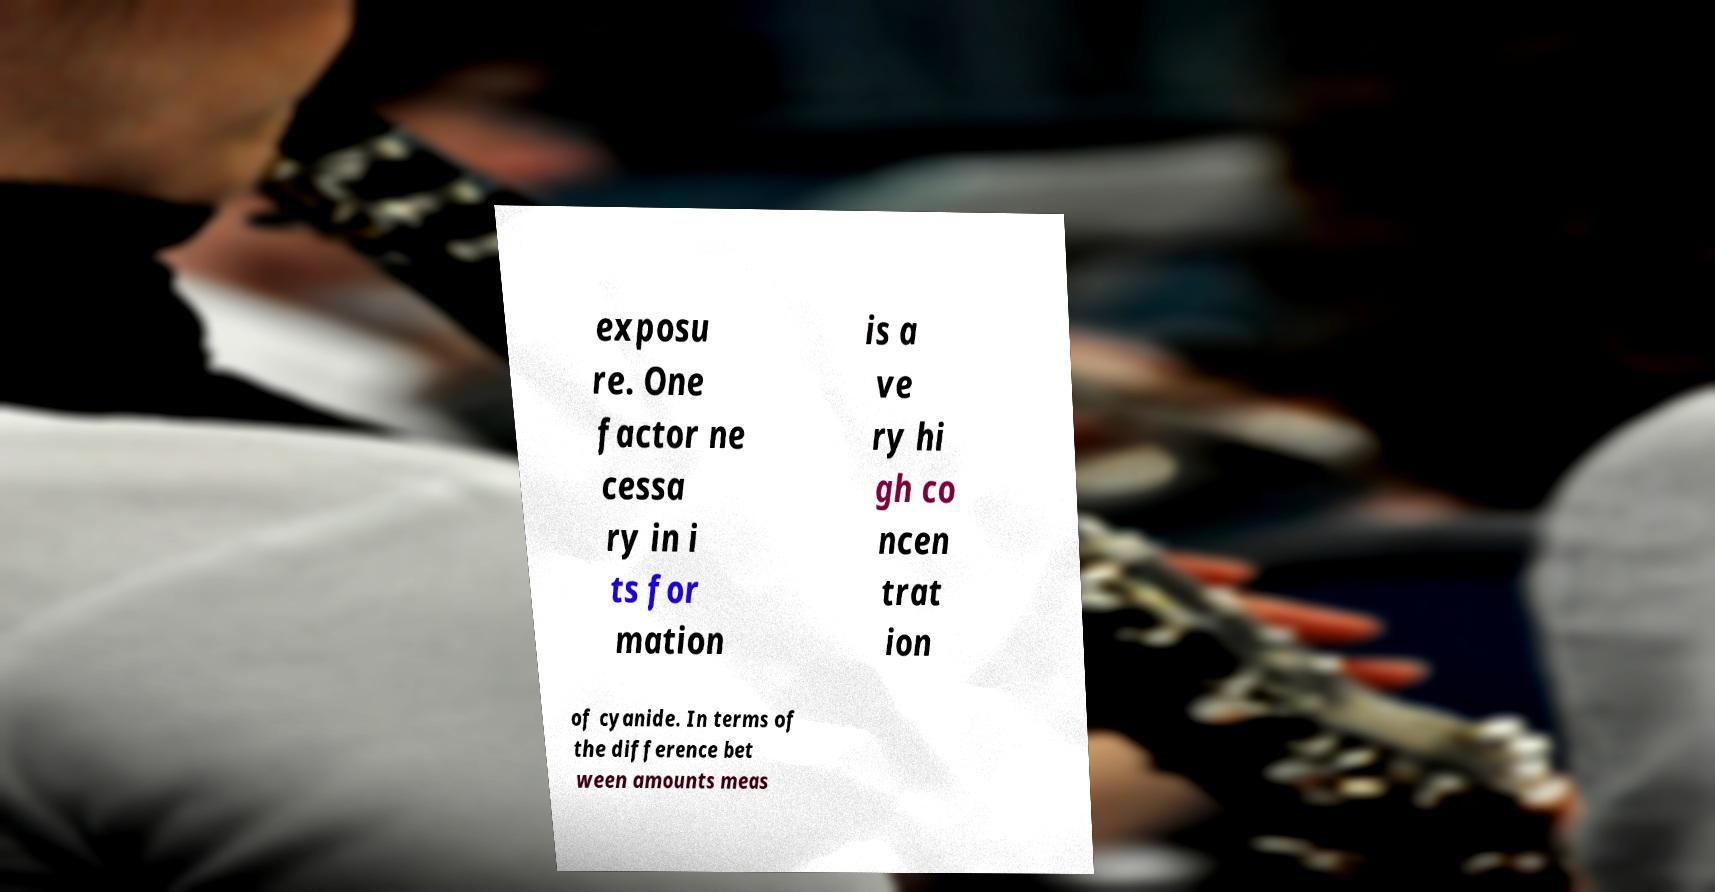Can you read and provide the text displayed in the image?This photo seems to have some interesting text. Can you extract and type it out for me? exposu re. One factor ne cessa ry in i ts for mation is a ve ry hi gh co ncen trat ion of cyanide. In terms of the difference bet ween amounts meas 